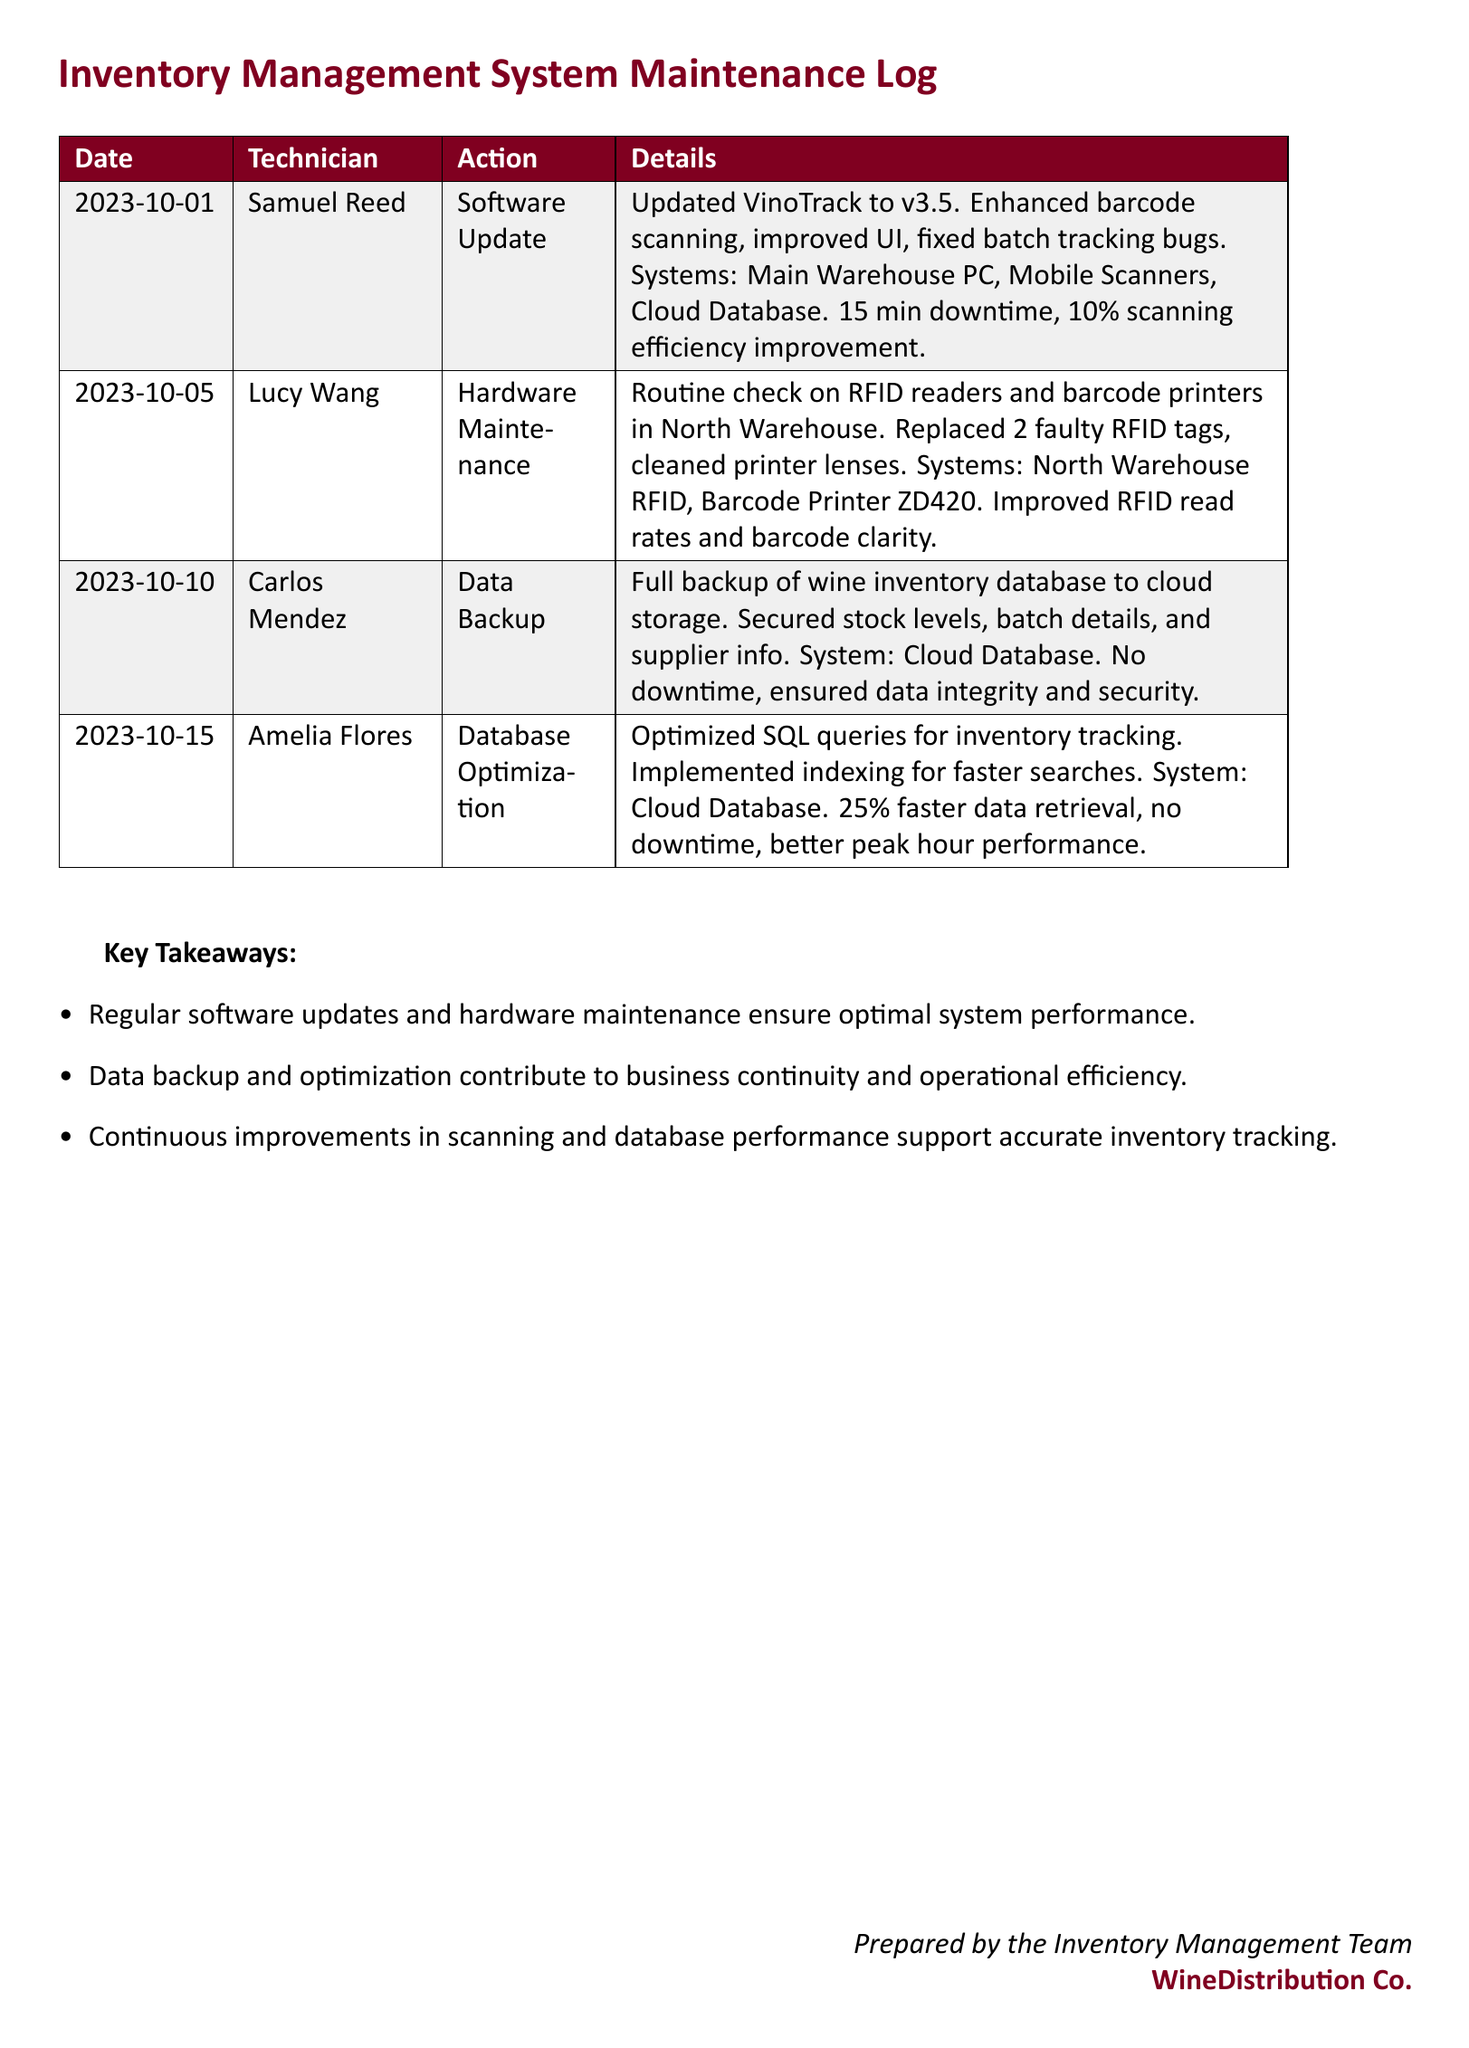What date was the software update performed? The software update was performed on the date listed in the document, which is clearly mentioned in the first row.
Answer: 2023-10-01 Who performed the database optimization? The technician who carried out the database optimization is mentioned in the details of the log.
Answer: Amelia Flores What was the improvement in scanning efficiency after the software update? The document states a specific percentage improvement after the software update, which is included in the details of the action.
Answer: 10% How many RFID tags were replaced during the hardware maintenance? The document mentions a specific quantity of RFID tags that were replaced in the hardware maintenance section.
Answer: 2 What system was optimized for faster data retrieval? The system that was optimized is detailed at the end of the database optimization entry.
Answer: Cloud Database What was the downtime during the software update? The downtime for the software update is clearly provided in the action description of the log.
Answer: 15 min Which technician performed the data backup? The name of the technician who completed the data backup is stated in the corresponding entry.
Answer: Carlos Mendez What action was taken on 2023-10-05? The action taken on that date is recorded in the hardware maintenance section of the log.
Answer: Hardware Maintenance 